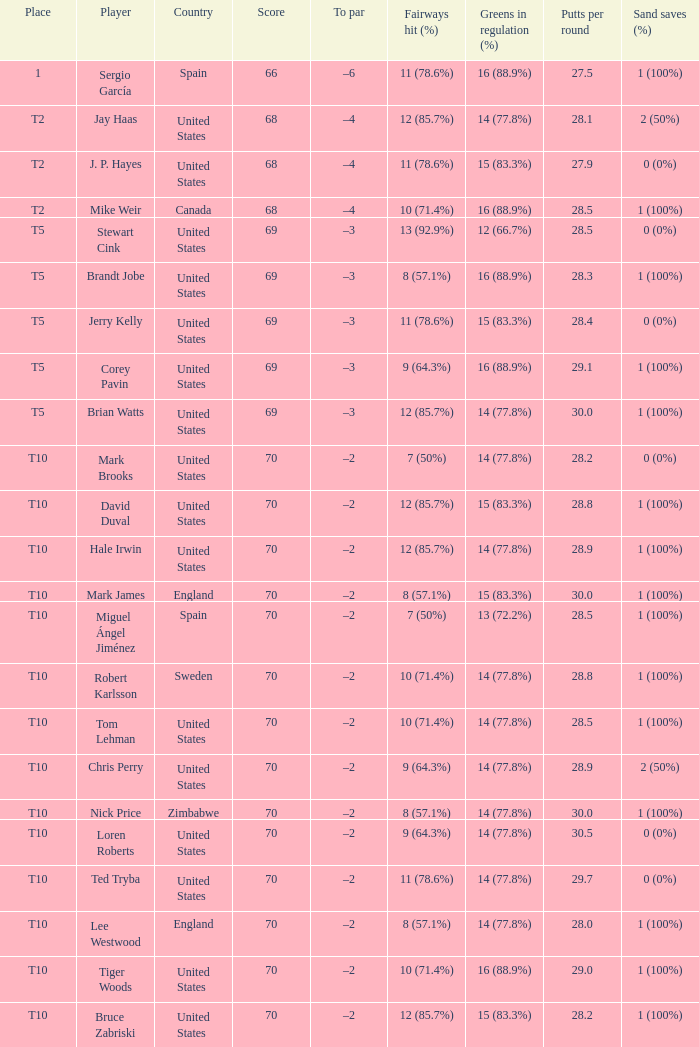What was the highest score of t5 place finisher brandt jobe? 69.0. Could you parse the entire table as a dict? {'header': ['Place', 'Player', 'Country', 'Score', 'To par', 'Fairways hit (%)', 'Greens in regulation (%)', 'Putts per round', 'Sand saves (%)'], 'rows': [['1', 'Sergio García', 'Spain', '66', '–6', '11 (78.6%)', '16 (88.9%)', '27.5', '1 (100%)'], ['T2', 'Jay Haas', 'United States', '68', '–4', '12 (85.7%)', '14 (77.8%)', '28.1', '2 (50%)'], ['T2', 'J. P. Hayes', 'United States', '68', '–4', '11 (78.6%)', '15 (83.3%)', '27.9', '0 (0%)'], ['T2', 'Mike Weir', 'Canada', '68', '–4', '10 (71.4%)', '16 (88.9%)', '28.5', '1 (100%)'], ['T5', 'Stewart Cink', 'United States', '69', '–3', '13 (92.9%)', '12 (66.7%)', '28.5', '0 (0%)'], ['T5', 'Brandt Jobe', 'United States', '69', '–3', '8 (57.1%)', '16 (88.9%)', '28.3', '1 (100%)'], ['T5', 'Jerry Kelly', 'United States', '69', '–3', '11 (78.6%)', '15 (83.3%)', '28.4', '0 (0%)'], ['T5', 'Corey Pavin', 'United States', '69', '–3', '9 (64.3%)', '16 (88.9%)', '29.1', '1 (100%)'], ['T5', 'Brian Watts', 'United States', '69', '–3', '12 (85.7%)', '14 (77.8%)', '30.0', '1 (100%)'], ['T10', 'Mark Brooks', 'United States', '70', '–2', '7 (50%)', '14 (77.8%)', '28.2', '0 (0%)'], ['T10', 'David Duval', 'United States', '70', '–2', '12 (85.7%)', '15 (83.3%)', '28.8', '1 (100%)'], ['T10', 'Hale Irwin', 'United States', '70', '–2', '12 (85.7%)', '14 (77.8%)', '28.9', '1 (100%)'], ['T10', 'Mark James', 'England', '70', '–2', '8 (57.1%)', '15 (83.3%)', '30.0', '1 (100%)'], ['T10', 'Miguel Ángel Jiménez', 'Spain', '70', '–2', '7 (50%)', '13 (72.2%)', '28.5', '1 (100%)'], ['T10', 'Robert Karlsson', 'Sweden', '70', '–2', '10 (71.4%)', '14 (77.8%)', '28.8', '1 (100%)'], ['T10', 'Tom Lehman', 'United States', '70', '–2', '10 (71.4%)', '14 (77.8%)', '28.5', '1 (100%)'], ['T10', 'Chris Perry', 'United States', '70', '–2', '9 (64.3%)', '14 (77.8%)', '28.9', '2 (50%)'], ['T10', 'Nick Price', 'Zimbabwe', '70', '–2', '8 (57.1%)', '14 (77.8%)', '30.0', '1 (100%)'], ['T10', 'Loren Roberts', 'United States', '70', '–2', '9 (64.3%)', '14 (77.8%)', '30.5', '0 (0%)'], ['T10', 'Ted Tryba', 'United States', '70', '–2', '11 (78.6%)', '14 (77.8%)', '29.7', '0 (0%)'], ['T10', 'Lee Westwood', 'England', '70', '–2', '8 (57.1%)', '14 (77.8%)', '28.0', '1 (100%)'], ['T10', 'Tiger Woods', 'United States', '70', '–2', '10 (71.4%)', '16 (88.9%)', '29.0', '1 (100%)'], ['T10', 'Bruce Zabriski', 'United States', '70', '–2', '12 (85.7%)', '15 (83.3%)', '28.2', '1 (100%)']]} 